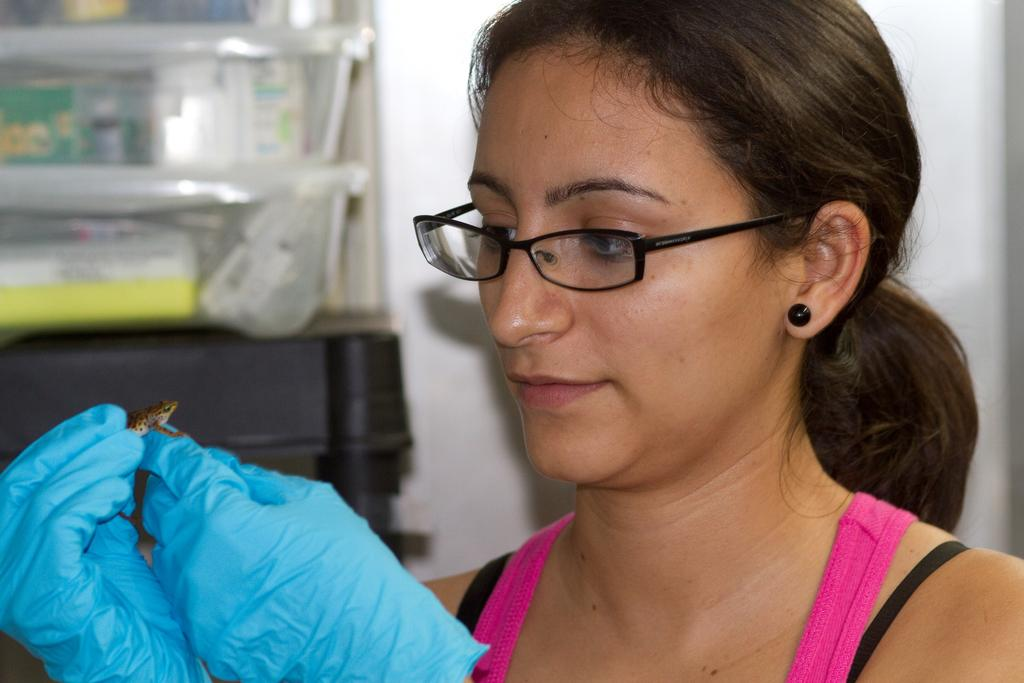Who or what is the main subject in the image? There is a person in the image. What is the person wearing on her hands? The person is wearing gloves. What is the person holding in her hand? The person is holding a frog with her hand. What can be seen on the left side of the image? There are boxes on the left side of the image. How many teeth can be seen in the image? There are no teeth visible in the image. Are there any boys present in the image? The provided facts do not mention any boys in the image. 